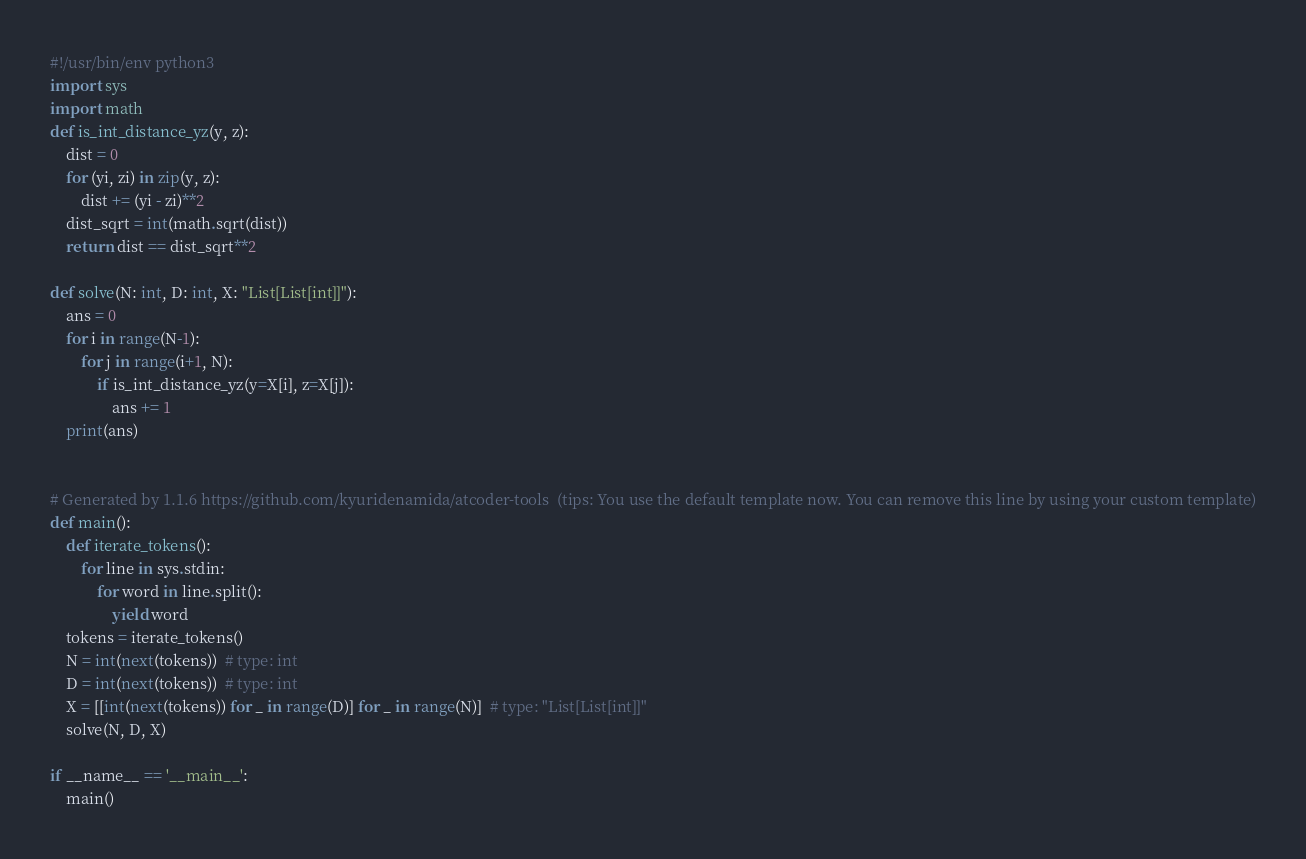Convert code to text. <code><loc_0><loc_0><loc_500><loc_500><_Python_>#!/usr/bin/env python3
import sys
import math
def is_int_distance_yz(y, z):
    dist = 0
    for (yi, zi) in zip(y, z):
        dist += (yi - zi)**2
    dist_sqrt = int(math.sqrt(dist))
    return dist == dist_sqrt**2

def solve(N: int, D: int, X: "List[List[int]]"):
    ans = 0
    for i in range(N-1):
        for j in range(i+1, N):
            if is_int_distance_yz(y=X[i], z=X[j]):
                ans += 1
    print(ans)


# Generated by 1.1.6 https://github.com/kyuridenamida/atcoder-tools  (tips: You use the default template now. You can remove this line by using your custom template)
def main():
    def iterate_tokens():
        for line in sys.stdin:
            for word in line.split():
                yield word
    tokens = iterate_tokens()
    N = int(next(tokens))  # type: int
    D = int(next(tokens))  # type: int
    X = [[int(next(tokens)) for _ in range(D)] for _ in range(N)]  # type: "List[List[int]]"
    solve(N, D, X)

if __name__ == '__main__':
    main()
</code> 